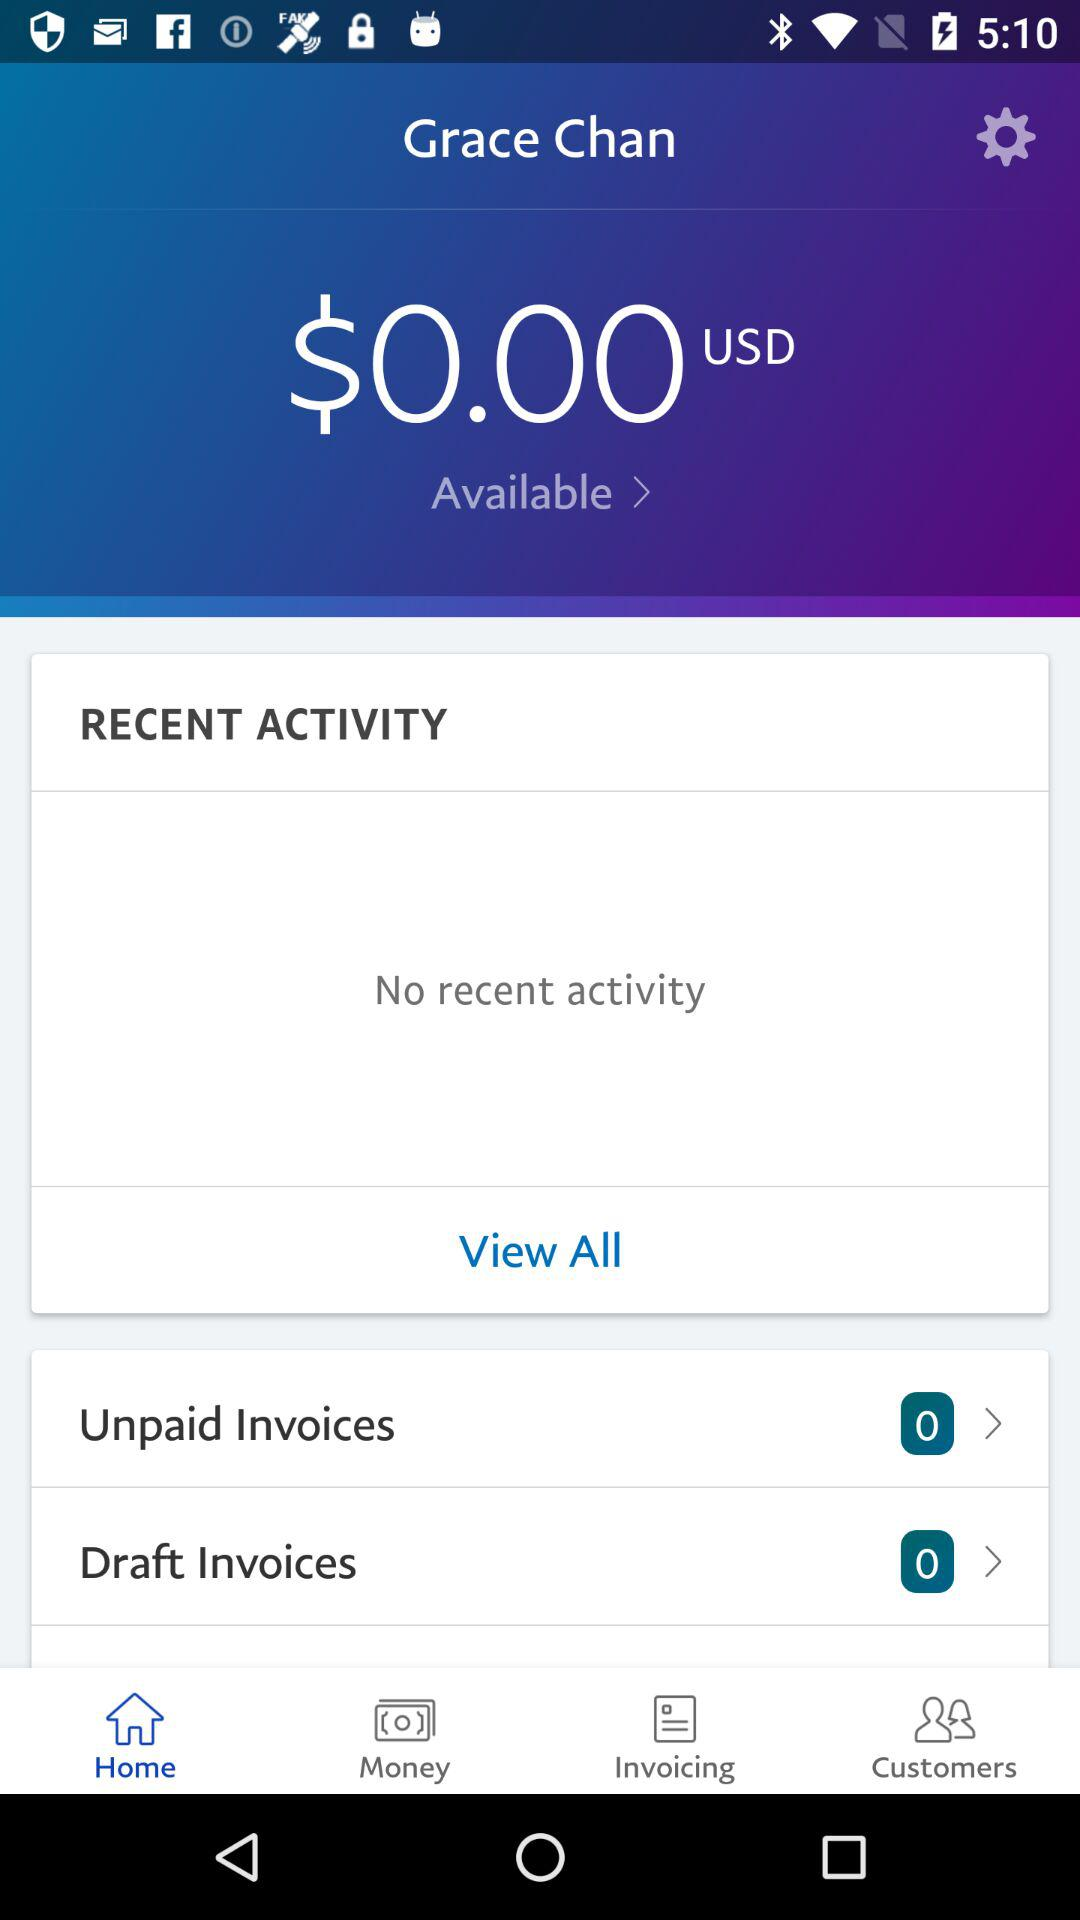What is the name of the user? The name of the user is Grace Chan. 